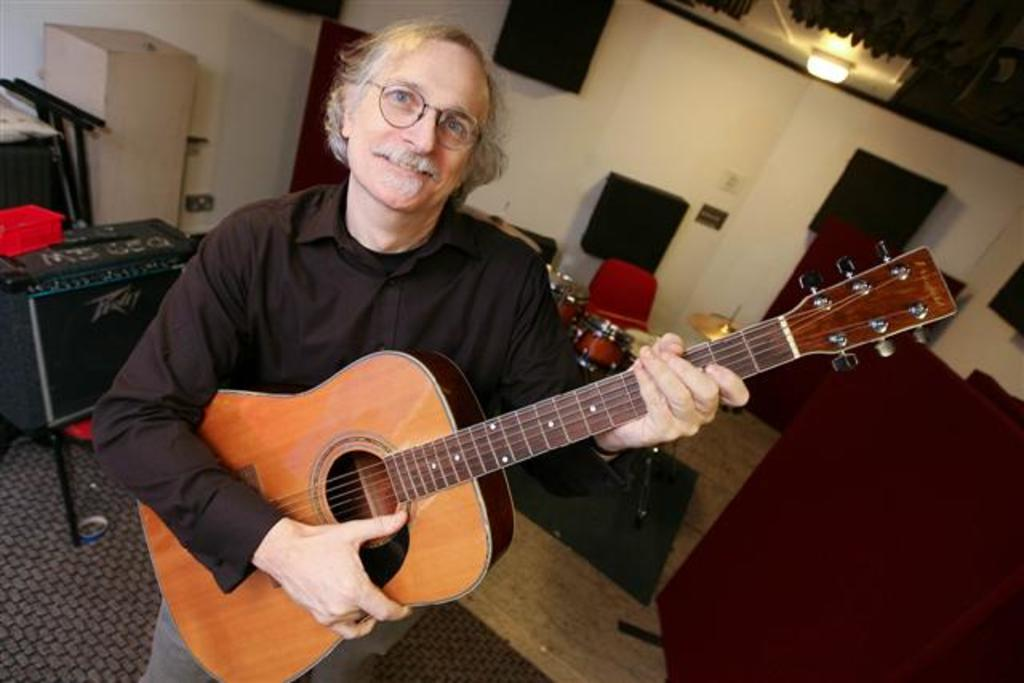What is the main subject of the image? The main subject of the image is a man. What is the man wearing? The man is wearing a black dress. What is the man doing in the image? The man is playing a guitar. What expression does the man have? The man is smiling. What other musical instruments are present in the image? There is a drum behind the man and other musical instruments beside him. What can be seen in the background of the image? There is a wall in the background of the image. What type of company is the man representing in the image? There is no indication in the image that the man is representing any company. What detail on the wall can be seen in the image? The provided facts do not mention any specific details on the wall, so we cannot answer this question definitively. 